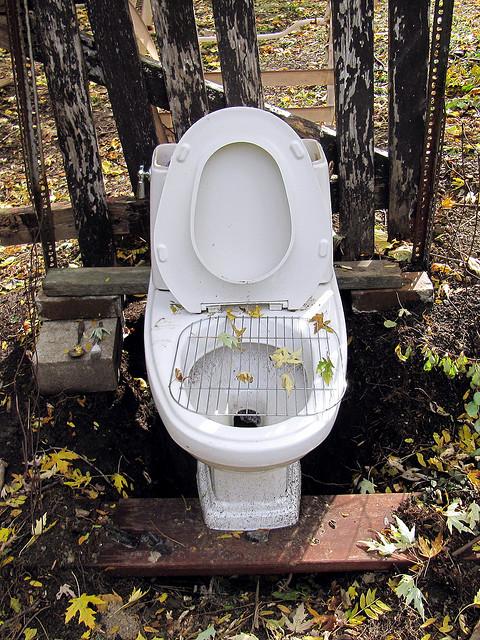Is the toilet lid up or down?
Be succinct. Up. What season was this picture taken?
Keep it brief. Fall. What is in the picture?
Keep it brief. Toilet. 